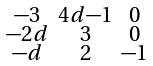Convert formula to latex. <formula><loc_0><loc_0><loc_500><loc_500>\begin{smallmatrix} - 3 & 4 d { - 1 } & 0 \\ - 2 d & 3 & 0 \\ - d & 2 & - 1 \end{smallmatrix}</formula> 